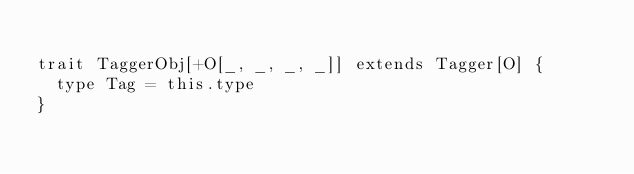<code> <loc_0><loc_0><loc_500><loc_500><_Scala_>
trait TaggerObj[+O[_, _, _, _]] extends Tagger[O] {
  type Tag = this.type
}
</code> 